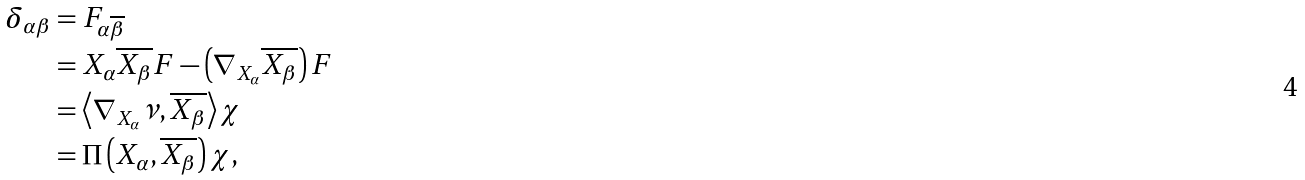<formula> <loc_0><loc_0><loc_500><loc_500>\delta _ { \alpha \beta } & = F _ { \alpha \overline { \beta } } \\ & = X _ { \alpha } \overline { X _ { \beta } } F - \left ( \nabla _ { X _ { \alpha } } \overline { X _ { \beta } } \right ) F \\ & = \left \langle \nabla _ { X _ { \alpha } } \nu , \overline { X _ { \beta } } \right \rangle \chi \\ & = \Pi \left ( X _ { \alpha } , \overline { X _ { \beta } } \right ) \chi ,</formula> 